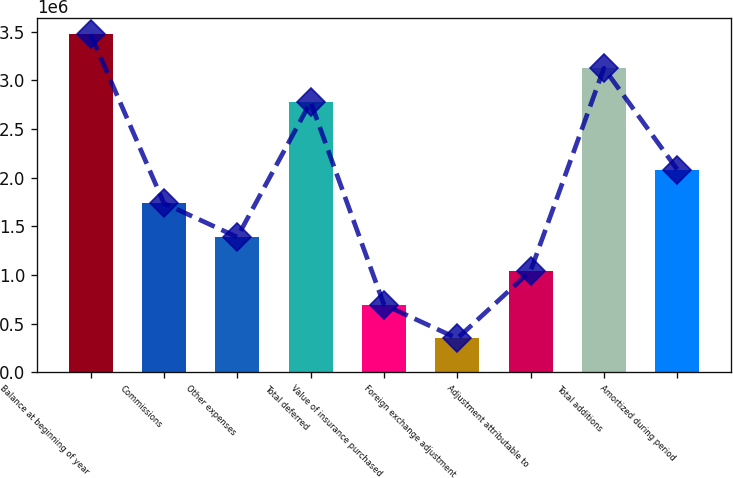Convert chart to OTSL. <chart><loc_0><loc_0><loc_500><loc_500><bar_chart><fcel>Balance at beginning of year<fcel>Commissions<fcel>Other expenses<fcel>Total deferred<fcel>Value of insurance purchased<fcel>Foreign exchange adjustment<fcel>Adjustment attributable to<fcel>Total additions<fcel>Amortized during period<nl><fcel>3.47178e+06<fcel>1.73589e+06<fcel>1.38871e+06<fcel>2.77743e+06<fcel>694359<fcel>347182<fcel>1.04154e+06<fcel>3.1246e+06<fcel>2.08307e+06<nl></chart> 